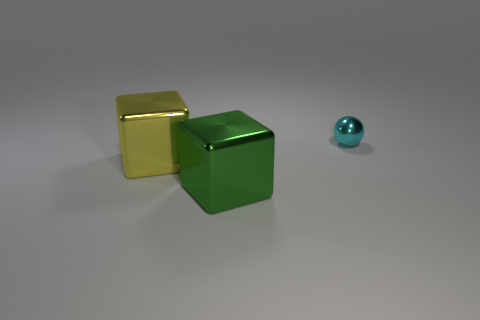There is a cyan metal ball; does it have the same size as the cube on the left side of the green object? Upon inspection, the cyan metal ball appears noticeably smaller in size when compared to the cube positioned to the left of the green object. The sizes of these objects are not the same. 